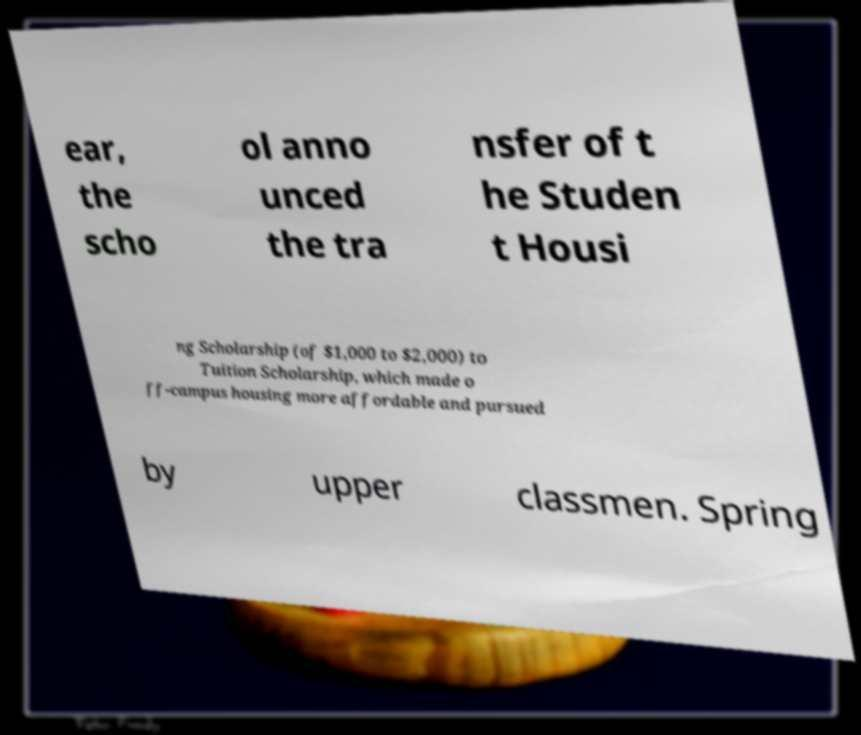Could you extract and type out the text from this image? ear, the scho ol anno unced the tra nsfer of t he Studen t Housi ng Scholarship (of $1,000 to $2,000) to Tuition Scholarship, which made o ff-campus housing more affordable and pursued by upper classmen. Spring 